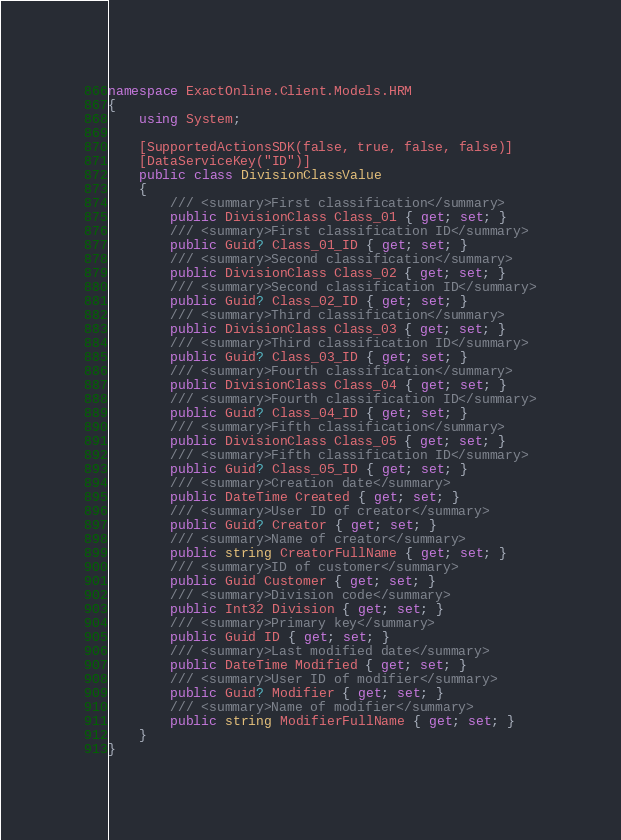<code> <loc_0><loc_0><loc_500><loc_500><_C#_>namespace ExactOnline.Client.Models.HRM
{
    using System;

    [SupportedActionsSDK(false, true, false, false)]
    [DataServiceKey("ID")]
    public class DivisionClassValue
    {
        /// <summary>First classification</summary>
        public DivisionClass Class_01 { get; set; }
        /// <summary>First classification ID</summary>
        public Guid? Class_01_ID { get; set; }
        /// <summary>Second classification</summary>
        public DivisionClass Class_02 { get; set; }
        /// <summary>Second classification ID</summary>
        public Guid? Class_02_ID { get; set; }
        /// <summary>Third classification</summary>
        public DivisionClass Class_03 { get; set; }
        /// <summary>Third classification ID</summary>
        public Guid? Class_03_ID { get; set; }
        /// <summary>Fourth classification</summary>
        public DivisionClass Class_04 { get; set; }
        /// <summary>Fourth classification ID</summary>
        public Guid? Class_04_ID { get; set; }
        /// <summary>Fifth classification</summary>
        public DivisionClass Class_05 { get; set; }
        /// <summary>Fifth classification ID</summary>
        public Guid? Class_05_ID { get; set; }
        /// <summary>Creation date</summary>
        public DateTime Created { get; set; }
        /// <summary>User ID of creator</summary>
        public Guid? Creator { get; set; }
        /// <summary>Name of creator</summary>
        public string CreatorFullName { get; set; }
        /// <summary>ID of customer</summary>
        public Guid Customer { get; set; }
        /// <summary>Division code</summary>
        public Int32 Division { get; set; }
        /// <summary>Primary key</summary>
        public Guid ID { get; set; }
        /// <summary>Last modified date</summary>
        public DateTime Modified { get; set; }
        /// <summary>User ID of modifier</summary>
        public Guid? Modifier { get; set; }
        /// <summary>Name of modifier</summary>
        public string ModifierFullName { get; set; }
    }
}</code> 